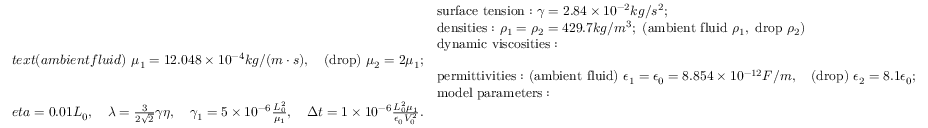<formula> <loc_0><loc_0><loc_500><loc_500>\begin{array} { r l } & { s u r f a c e t e n s i o n \colon \ \gamma = 2 . 8 4 \times 1 0 ^ { - 2 } k g / s ^ { 2 } ; } \\ & { d e n s i t i e s \colon \ \rho _ { 1 } = \rho _ { 2 } = 4 2 9 . 7 k g / m ^ { 3 } ; \ ( a m b i e n t f l u i d \ \rho _ { 1 } , \ d r o p \ \rho _ { 2 } ) } \\ & { d y n a m i c v i s \cos i t i e s \colon } \\ { t e x t { ( a m b i e n t f l u i d ) } \ \mu _ { 1 } = 1 2 . 0 4 8 \times 1 0 ^ { - 4 } k g / ( m \cdot s ) , \quad ( d r o p ) \ \mu _ { 2 } = 2 \mu _ { 1 } ; } \\ & { p e r m i t t i v i t i e s \colon \ ( a m b i e n t f l u i d ) \ \epsilon _ { 1 } = \epsilon _ { 0 } = 8 . 8 5 4 \times 1 0 ^ { - 1 2 } F / m , \quad ( d r o p ) \ \epsilon _ { 2 } = 8 . 1 \epsilon _ { 0 } ; } \\ & { m o d e l p a r a m e t e r s \colon } \\ { e t a = 0 . 0 1 L _ { 0 } , \quad \lambda = \frac { 3 } { 2 \sqrt { 2 } } \gamma \eta , \quad \gamma _ { 1 } = 5 \times 1 0 ^ { - 6 } \frac { L _ { 0 } ^ { 2 } } { \mu _ { 1 } } , \quad \Delta t = 1 \times 1 0 ^ { - 6 } \frac { L _ { 0 } ^ { 2 } \mu _ { 1 } } { \epsilon _ { 0 } V _ { 0 } ^ { 2 } } . } \end{array}</formula> 